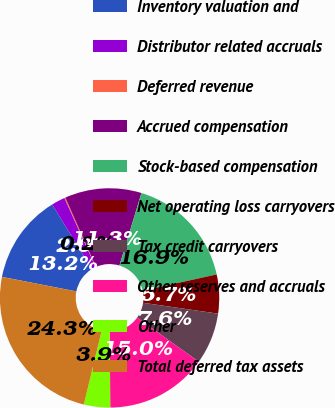Convert chart to OTSL. <chart><loc_0><loc_0><loc_500><loc_500><pie_chart><fcel>Inventory valuation and<fcel>Distributor related accruals<fcel>Deferred revenue<fcel>Accrued compensation<fcel>Stock-based compensation<fcel>Net operating loss carryovers<fcel>Tax credit carryovers<fcel>Other reserves and accruals<fcel>Other<fcel>Total deferred tax assets<nl><fcel>13.16%<fcel>2.01%<fcel>0.15%<fcel>11.3%<fcel>16.87%<fcel>5.73%<fcel>7.59%<fcel>15.02%<fcel>3.87%<fcel>24.3%<nl></chart> 